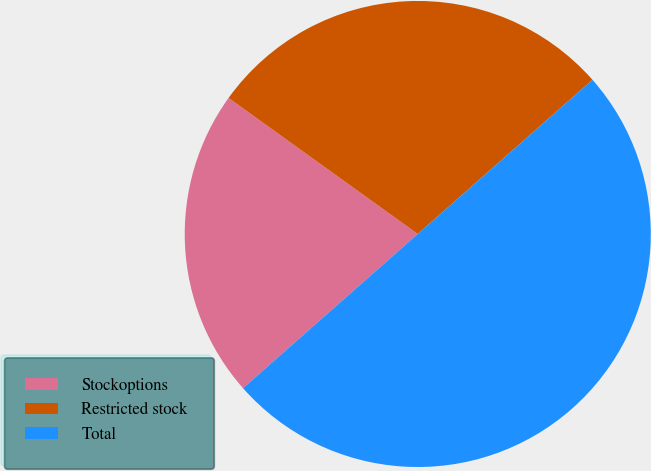<chart> <loc_0><loc_0><loc_500><loc_500><pie_chart><fcel>Stockoptions<fcel>Restricted stock<fcel>Total<nl><fcel>21.43%<fcel>28.57%<fcel>50.0%<nl></chart> 